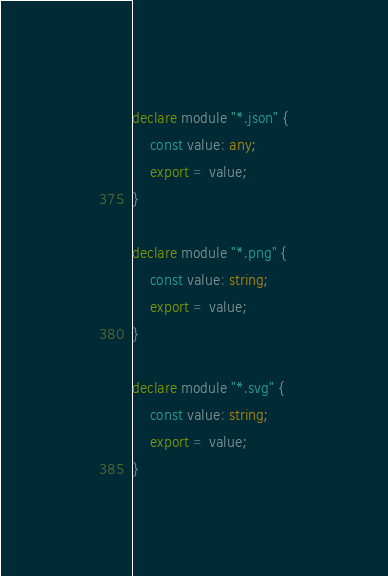Convert code to text. <code><loc_0><loc_0><loc_500><loc_500><_TypeScript_>declare module "*.json" {
    const value: any;
    export = value;
}

declare module "*.png" {
    const value: string;
    export = value;
}

declare module "*.svg" {
    const value: string;
    export = value;
}
</code> 